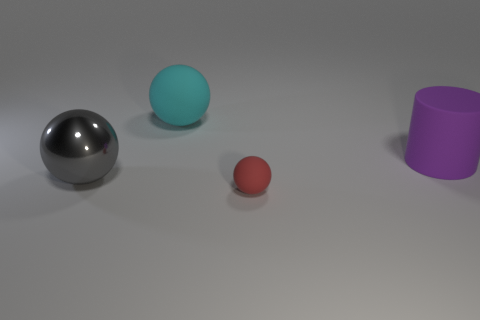Are there any other things that are made of the same material as the large gray object?
Give a very brief answer. No. Is the color of the shiny object the same as the tiny thing?
Your response must be concise. No. Are there fewer small matte things behind the cyan ball than tiny red matte balls behind the tiny red rubber object?
Keep it short and to the point. No. The cylinder has what color?
Give a very brief answer. Purple. What number of large objects are the same color as the big shiny sphere?
Your answer should be compact. 0. There is a big purple matte object; are there any big gray things left of it?
Give a very brief answer. Yes. Is the number of tiny rubber things left of the big cyan matte sphere the same as the number of cylinders that are in front of the red sphere?
Your answer should be very brief. Yes. There is a sphere behind the big purple cylinder; does it have the same size as the rubber thing in front of the large gray metal sphere?
Offer a terse response. No. What shape is the matte thing that is right of the ball that is right of the rubber sphere behind the purple matte thing?
Your answer should be compact. Cylinder. The other gray object that is the same shape as the tiny rubber thing is what size?
Keep it short and to the point. Large. 